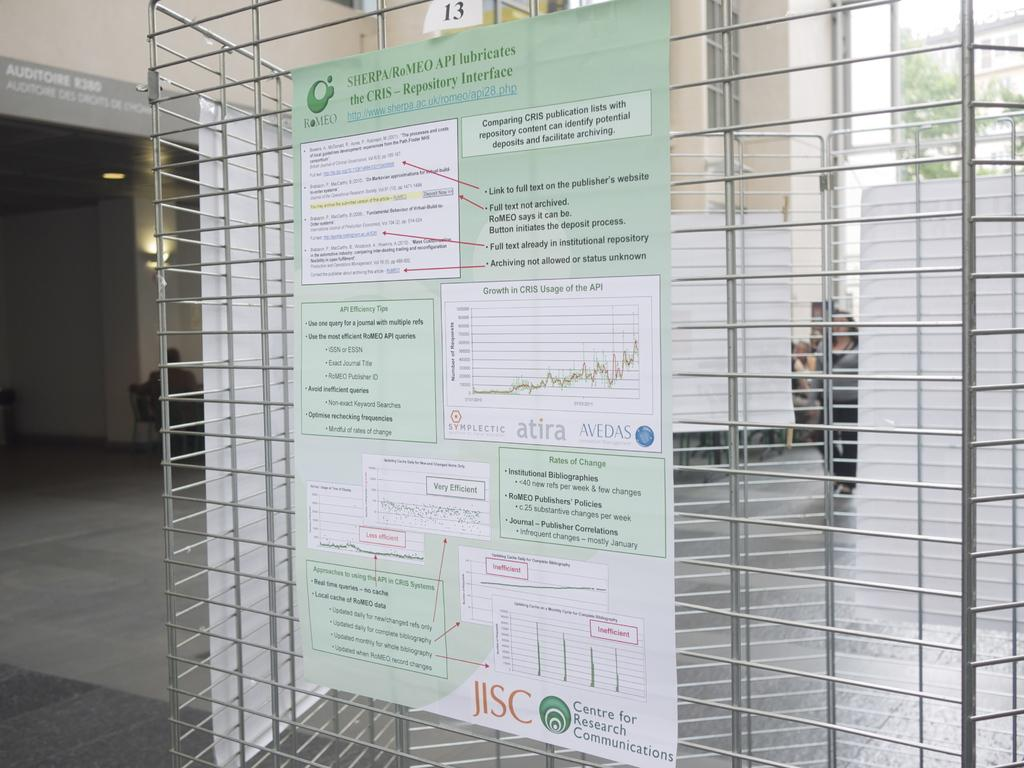<image>
Describe the image concisely. a poster on a cage that is labeled 'jisc' at the bottom 